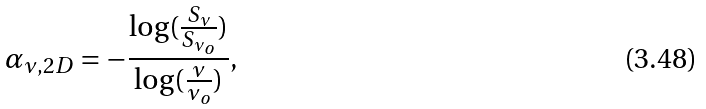Convert formula to latex. <formula><loc_0><loc_0><loc_500><loc_500>\alpha _ { \nu , 2 D } = - \frac { \log ( \frac { S _ { \nu } } { S _ { \nu _ { o } } } ) } { \log ( \frac { \nu } { \nu _ { o } } ) } ,</formula> 